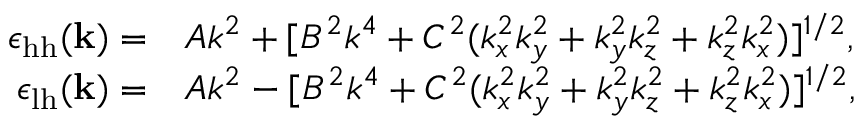Convert formula to latex. <formula><loc_0><loc_0><loc_500><loc_500>\begin{array} { r l } { \epsilon _ { h h } ( \mathbf k ) = } & { A k ^ { 2 } + [ B ^ { 2 } k ^ { 4 } + C ^ { 2 } ( k _ { x } ^ { 2 } k _ { y } ^ { 2 } + k _ { y } ^ { 2 } k _ { z } ^ { 2 } + k _ { z } ^ { 2 } k _ { x } ^ { 2 } ) ] ^ { 1 / 2 } , } \\ { \epsilon _ { l h } ( \mathbf k ) = } & { A k ^ { 2 } - [ B ^ { 2 } k ^ { 4 } + C ^ { 2 } ( k _ { x } ^ { 2 } k _ { y } ^ { 2 } + k _ { y } ^ { 2 } k _ { z } ^ { 2 } + k _ { z } ^ { 2 } k _ { x } ^ { 2 } ) ] ^ { 1 / 2 } , } \end{array}</formula> 